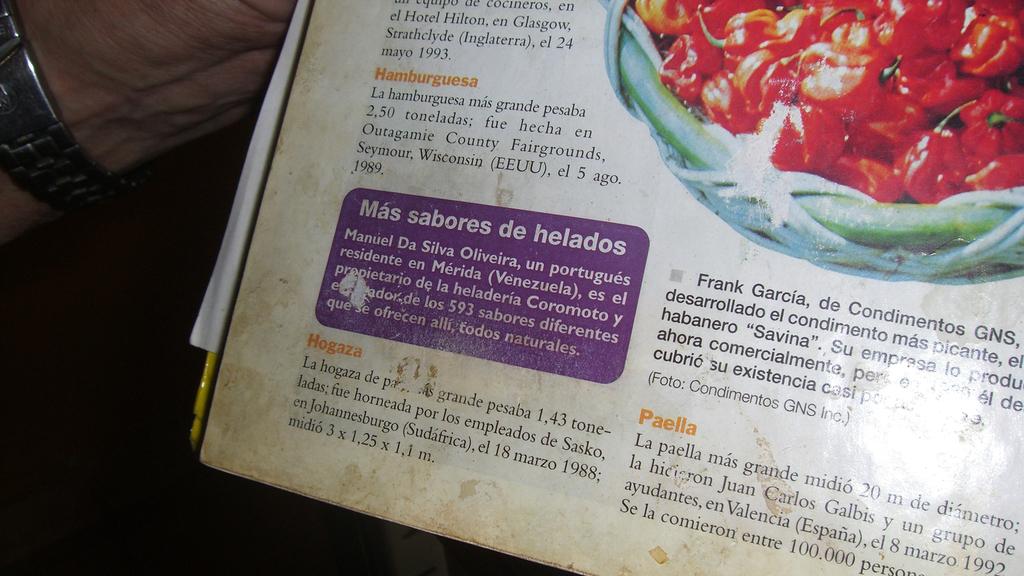What is the world after sabores de?
Offer a very short reply. Helados. 